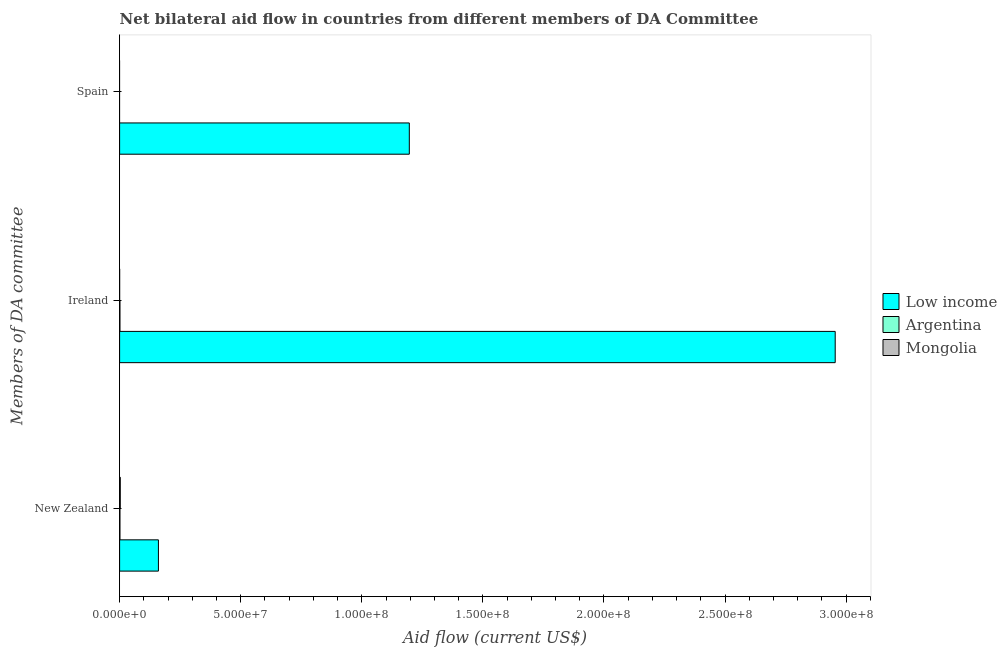How many different coloured bars are there?
Provide a succinct answer. 3. Are the number of bars per tick equal to the number of legend labels?
Provide a succinct answer. No. What is the label of the 2nd group of bars from the top?
Give a very brief answer. Ireland. What is the amount of aid provided by new zealand in Low income?
Offer a terse response. 1.60e+07. Across all countries, what is the maximum amount of aid provided by new zealand?
Provide a short and direct response. 1.60e+07. Across all countries, what is the minimum amount of aid provided by ireland?
Provide a succinct answer. 10000. What is the total amount of aid provided by new zealand in the graph?
Offer a very short reply. 1.64e+07. What is the difference between the amount of aid provided by ireland in Mongolia and that in Argentina?
Give a very brief answer. -1.30e+05. What is the difference between the amount of aid provided by new zealand in Low income and the amount of aid provided by ireland in Mongolia?
Your answer should be compact. 1.60e+07. What is the average amount of aid provided by spain per country?
Your answer should be compact. 3.99e+07. What is the difference between the amount of aid provided by new zealand and amount of aid provided by spain in Low income?
Ensure brevity in your answer.  -1.04e+08. What is the ratio of the amount of aid provided by ireland in Low income to that in Mongolia?
Provide a short and direct response. 2.95e+04. What is the difference between the highest and the second highest amount of aid provided by ireland?
Keep it short and to the point. 2.95e+08. What is the difference between the highest and the lowest amount of aid provided by new zealand?
Your answer should be very brief. 1.59e+07. In how many countries, is the amount of aid provided by ireland greater than the average amount of aid provided by ireland taken over all countries?
Ensure brevity in your answer.  1. Is it the case that in every country, the sum of the amount of aid provided by new zealand and amount of aid provided by ireland is greater than the amount of aid provided by spain?
Offer a terse response. Yes. How many bars are there?
Your answer should be compact. 7. Are all the bars in the graph horizontal?
Provide a succinct answer. Yes. How many countries are there in the graph?
Provide a short and direct response. 3. Are the values on the major ticks of X-axis written in scientific E-notation?
Give a very brief answer. Yes. Where does the legend appear in the graph?
Make the answer very short. Center right. What is the title of the graph?
Offer a very short reply. Net bilateral aid flow in countries from different members of DA Committee. What is the label or title of the Y-axis?
Make the answer very short. Members of DA committee. What is the Aid flow (current US$) in Low income in New Zealand?
Provide a succinct answer. 1.60e+07. What is the Aid flow (current US$) of Low income in Ireland?
Offer a very short reply. 2.95e+08. What is the Aid flow (current US$) in Argentina in Ireland?
Your answer should be compact. 1.40e+05. What is the Aid flow (current US$) of Low income in Spain?
Your answer should be very brief. 1.20e+08. What is the Aid flow (current US$) in Mongolia in Spain?
Offer a very short reply. 0. Across all Members of DA committee, what is the maximum Aid flow (current US$) of Low income?
Provide a short and direct response. 2.95e+08. Across all Members of DA committee, what is the maximum Aid flow (current US$) in Argentina?
Give a very brief answer. 1.40e+05. Across all Members of DA committee, what is the maximum Aid flow (current US$) in Mongolia?
Offer a very short reply. 2.80e+05. Across all Members of DA committee, what is the minimum Aid flow (current US$) of Low income?
Offer a terse response. 1.60e+07. What is the total Aid flow (current US$) in Low income in the graph?
Your answer should be very brief. 4.31e+08. What is the difference between the Aid flow (current US$) in Low income in New Zealand and that in Ireland?
Keep it short and to the point. -2.79e+08. What is the difference between the Aid flow (current US$) of Argentina in New Zealand and that in Ireland?
Provide a short and direct response. 0. What is the difference between the Aid flow (current US$) of Low income in New Zealand and that in Spain?
Provide a short and direct response. -1.04e+08. What is the difference between the Aid flow (current US$) of Low income in Ireland and that in Spain?
Make the answer very short. 1.76e+08. What is the difference between the Aid flow (current US$) in Low income in New Zealand and the Aid flow (current US$) in Argentina in Ireland?
Your answer should be compact. 1.59e+07. What is the difference between the Aid flow (current US$) in Low income in New Zealand and the Aid flow (current US$) in Mongolia in Ireland?
Your answer should be very brief. 1.60e+07. What is the average Aid flow (current US$) of Low income per Members of DA committee?
Your response must be concise. 1.44e+08. What is the average Aid flow (current US$) of Argentina per Members of DA committee?
Offer a very short reply. 9.33e+04. What is the average Aid flow (current US$) in Mongolia per Members of DA committee?
Your answer should be very brief. 9.67e+04. What is the difference between the Aid flow (current US$) of Low income and Aid flow (current US$) of Argentina in New Zealand?
Keep it short and to the point. 1.59e+07. What is the difference between the Aid flow (current US$) in Low income and Aid flow (current US$) in Mongolia in New Zealand?
Offer a terse response. 1.58e+07. What is the difference between the Aid flow (current US$) of Low income and Aid flow (current US$) of Argentina in Ireland?
Your answer should be compact. 2.95e+08. What is the difference between the Aid flow (current US$) of Low income and Aid flow (current US$) of Mongolia in Ireland?
Offer a terse response. 2.95e+08. What is the ratio of the Aid flow (current US$) in Low income in New Zealand to that in Ireland?
Ensure brevity in your answer.  0.05. What is the ratio of the Aid flow (current US$) of Argentina in New Zealand to that in Ireland?
Your response must be concise. 1. What is the ratio of the Aid flow (current US$) of Low income in New Zealand to that in Spain?
Your answer should be very brief. 0.13. What is the ratio of the Aid flow (current US$) in Low income in Ireland to that in Spain?
Offer a very short reply. 2.47. What is the difference between the highest and the second highest Aid flow (current US$) in Low income?
Keep it short and to the point. 1.76e+08. What is the difference between the highest and the lowest Aid flow (current US$) in Low income?
Keep it short and to the point. 2.79e+08. What is the difference between the highest and the lowest Aid flow (current US$) of Argentina?
Your response must be concise. 1.40e+05. What is the difference between the highest and the lowest Aid flow (current US$) of Mongolia?
Your response must be concise. 2.80e+05. 